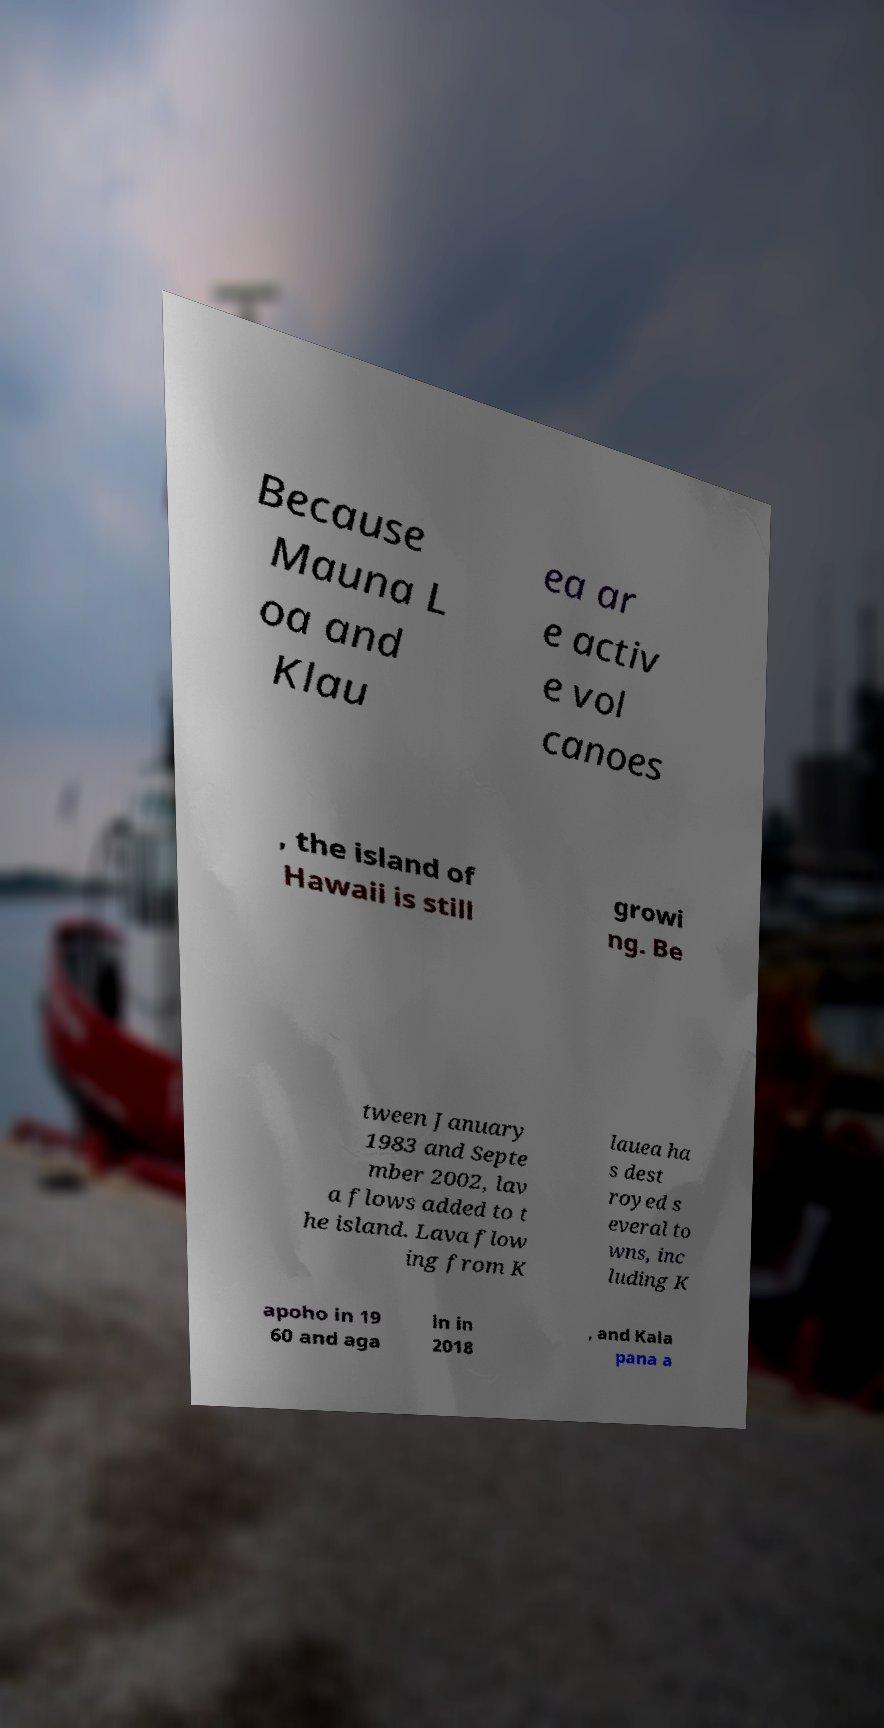Can you read and provide the text displayed in the image?This photo seems to have some interesting text. Can you extract and type it out for me? Because Mauna L oa and Klau ea ar e activ e vol canoes , the island of Hawaii is still growi ng. Be tween January 1983 and Septe mber 2002, lav a flows added to t he island. Lava flow ing from K lauea ha s dest royed s everal to wns, inc luding K apoho in 19 60 and aga in in 2018 , and Kala pana a 